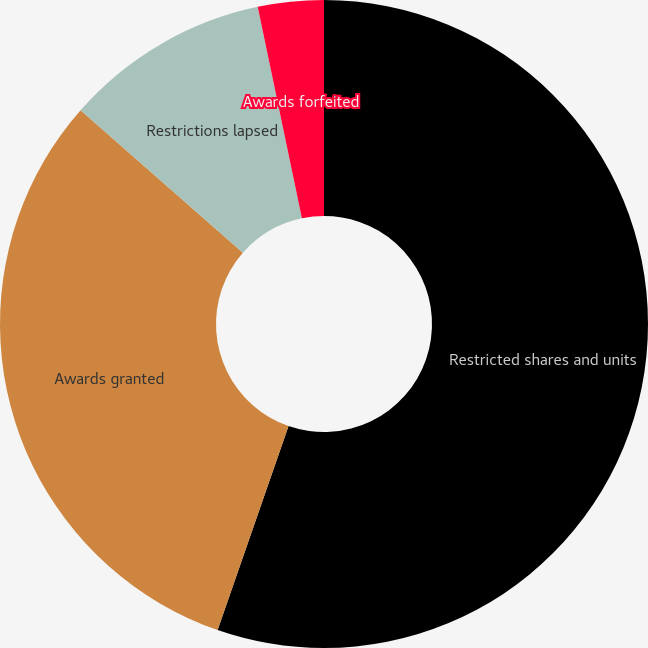<chart> <loc_0><loc_0><loc_500><loc_500><pie_chart><fcel>Restricted shares and units<fcel>Awards granted<fcel>Restrictions lapsed<fcel>Awards forfeited<nl><fcel>55.33%<fcel>31.15%<fcel>10.25%<fcel>3.28%<nl></chart> 